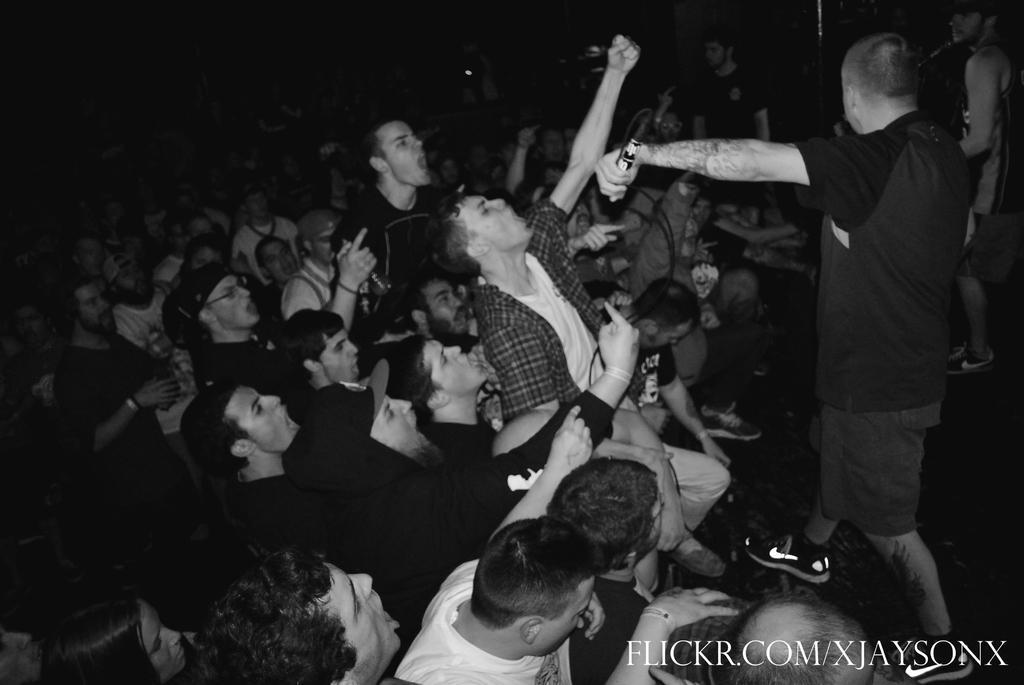Please provide a concise description of this image. This is a black and white image. Here I can see a crowd of people. On the right side I can see a man standing and holding a mike in hand. It seems like these people are shouting. On the right bottom of the image I can see some text. 